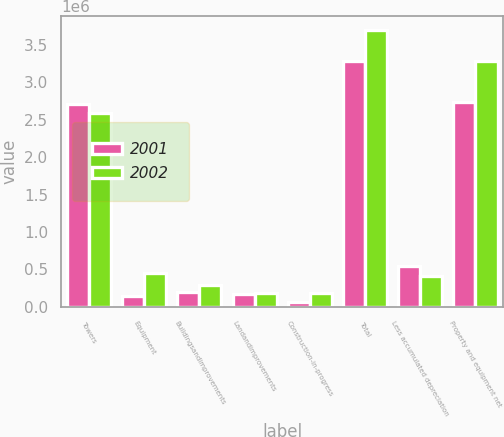Convert chart. <chart><loc_0><loc_0><loc_500><loc_500><stacked_bar_chart><ecel><fcel>Towers<fcel>Equipment<fcel>Buildingsandimprovements<fcel>Landandimprovements<fcel>Construction-in-progress<fcel>Total<fcel>Less accumulated depreciation<fcel>Property and equipment net<nl><fcel>2001<fcel>2.706e+06<fcel>140786<fcel>194962<fcel>178466<fcel>63844<fcel>3.28406e+06<fcel>549178<fcel>2.73488e+06<nl><fcel>2002<fcel>2.58862e+06<fcel>459369<fcel>287732<fcel>182260<fcel>180042<fcel>3.69802e+06<fcel>410446<fcel>3.28757e+06<nl></chart> 